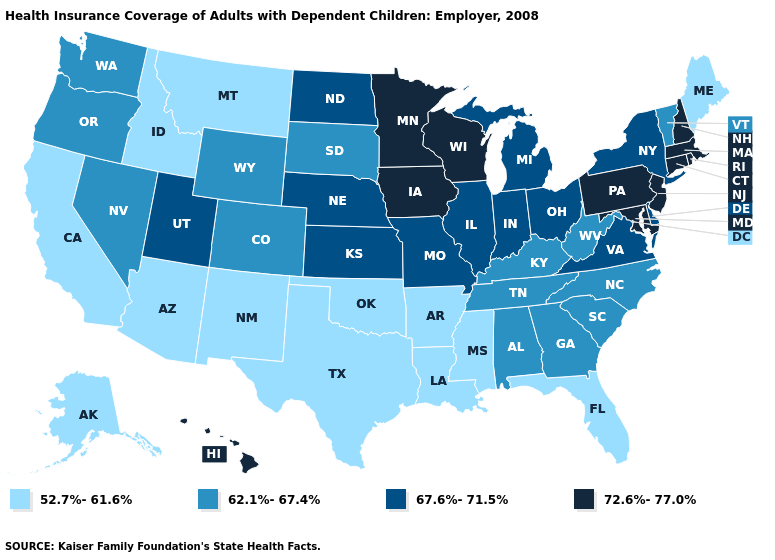Name the states that have a value in the range 72.6%-77.0%?
Answer briefly. Connecticut, Hawaii, Iowa, Maryland, Massachusetts, Minnesota, New Hampshire, New Jersey, Pennsylvania, Rhode Island, Wisconsin. What is the lowest value in the West?
Concise answer only. 52.7%-61.6%. Does the first symbol in the legend represent the smallest category?
Short answer required. Yes. Does California have a lower value than Virginia?
Give a very brief answer. Yes. Name the states that have a value in the range 62.1%-67.4%?
Concise answer only. Alabama, Colorado, Georgia, Kentucky, Nevada, North Carolina, Oregon, South Carolina, South Dakota, Tennessee, Vermont, Washington, West Virginia, Wyoming. What is the highest value in states that border Texas?
Be succinct. 52.7%-61.6%. Which states hav the highest value in the West?
Quick response, please. Hawaii. Name the states that have a value in the range 67.6%-71.5%?
Give a very brief answer. Delaware, Illinois, Indiana, Kansas, Michigan, Missouri, Nebraska, New York, North Dakota, Ohio, Utah, Virginia. What is the value of North Carolina?
Concise answer only. 62.1%-67.4%. What is the value of Utah?
Keep it brief. 67.6%-71.5%. Which states have the lowest value in the USA?
Answer briefly. Alaska, Arizona, Arkansas, California, Florida, Idaho, Louisiana, Maine, Mississippi, Montana, New Mexico, Oklahoma, Texas. What is the highest value in states that border South Carolina?
Concise answer only. 62.1%-67.4%. Does Oregon have the lowest value in the USA?
Be succinct. No. Among the states that border New Jersey , which have the highest value?
Write a very short answer. Pennsylvania. Does California have the highest value in the USA?
Answer briefly. No. 